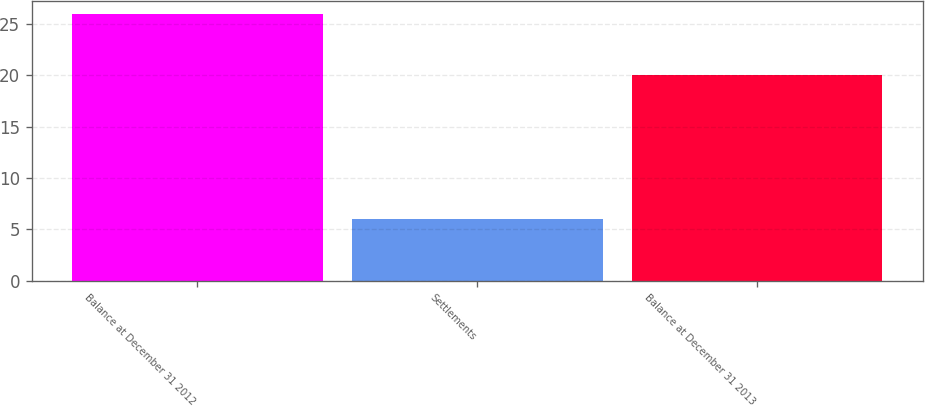<chart> <loc_0><loc_0><loc_500><loc_500><bar_chart><fcel>Balance at December 31 2012<fcel>Settlements<fcel>Balance at December 31 2013<nl><fcel>26<fcel>6<fcel>20<nl></chart> 